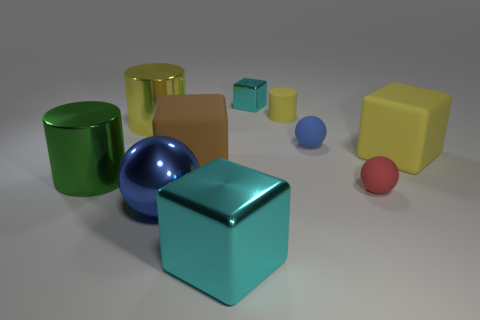Could you describe the textures that are visible on the objects in the image? Certainly! The objects in the image display a variety of textures. The cyan cube and the green and yellow cylinders have smooth and shiny surfaces indicative of a metallic or glossy finish. The blue sphere and the small cubes appear similarly reflective but with slightly subtle textures that suggest a smooth, hard finish. The tan cube exhibits a matte surface, which appears to diffuse light rather than reflect it. 